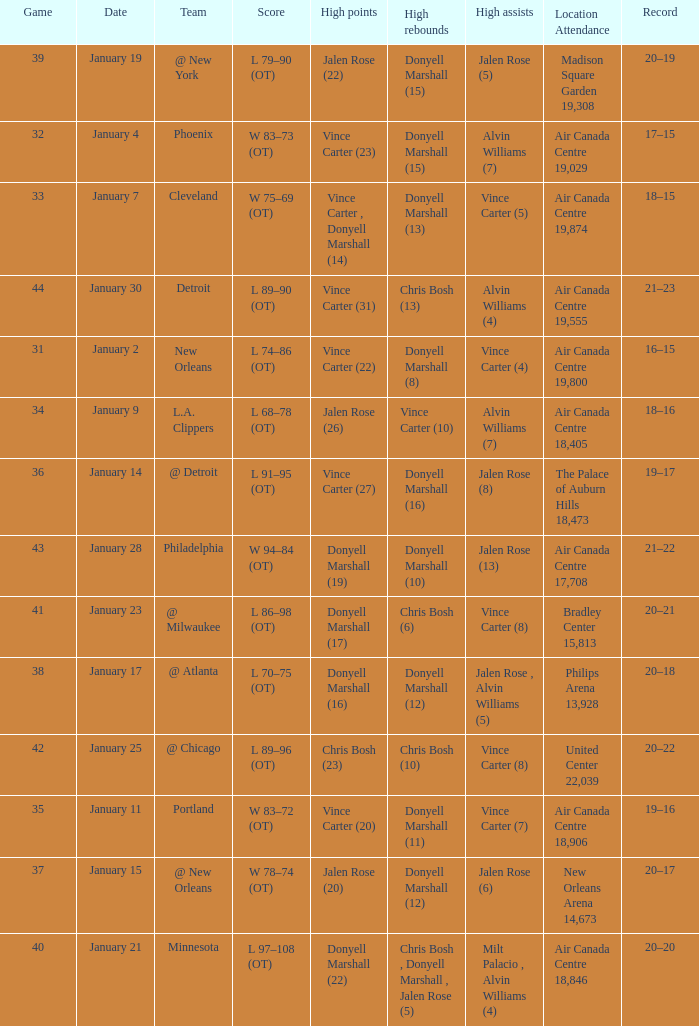What is the Location and Attendance with a Record of 21–22? Air Canada Centre 17,708. 